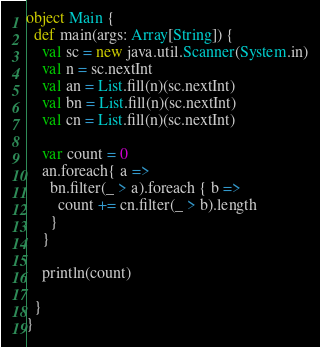Convert code to text. <code><loc_0><loc_0><loc_500><loc_500><_Scala_>object Main {
  def main(args: Array[String]) {
    val sc = new java.util.Scanner(System.in)
    val n = sc.nextInt
    val an = List.fill(n)(sc.nextInt)
    val bn = List.fill(n)(sc.nextInt)
    val cn = List.fill(n)(sc.nextInt)

    var count = 0
    an.foreach{ a =>
      bn.filter(_ > a).foreach { b =>
        count += cn.filter(_ > b).length
      }
    }

    println(count)

  }
}
</code> 